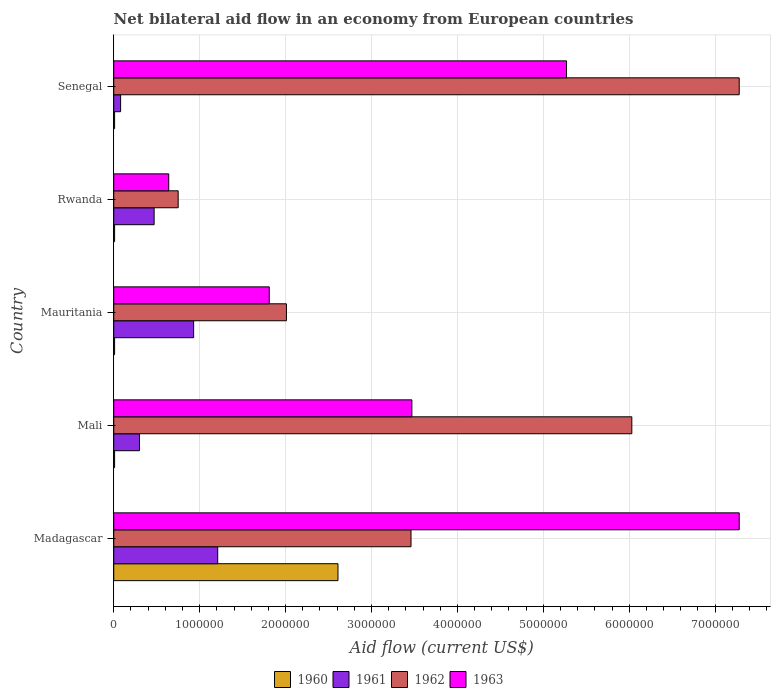How many groups of bars are there?
Your response must be concise. 5. How many bars are there on the 4th tick from the bottom?
Ensure brevity in your answer.  4. What is the label of the 1st group of bars from the top?
Provide a short and direct response. Senegal. What is the net bilateral aid flow in 1961 in Mauritania?
Your answer should be very brief. 9.30e+05. Across all countries, what is the maximum net bilateral aid flow in 1962?
Provide a succinct answer. 7.28e+06. Across all countries, what is the minimum net bilateral aid flow in 1963?
Your answer should be very brief. 6.40e+05. In which country was the net bilateral aid flow in 1961 maximum?
Your answer should be compact. Madagascar. In which country was the net bilateral aid flow in 1961 minimum?
Provide a succinct answer. Senegal. What is the total net bilateral aid flow in 1961 in the graph?
Your response must be concise. 2.99e+06. What is the difference between the net bilateral aid flow in 1962 in Mali and that in Senegal?
Your answer should be compact. -1.25e+06. What is the average net bilateral aid flow in 1961 per country?
Give a very brief answer. 5.98e+05. What is the difference between the net bilateral aid flow in 1962 and net bilateral aid flow in 1963 in Senegal?
Your answer should be very brief. 2.01e+06. What is the ratio of the net bilateral aid flow in 1963 in Mali to that in Senegal?
Your response must be concise. 0.66. Is the net bilateral aid flow in 1960 in Mauritania less than that in Rwanda?
Ensure brevity in your answer.  No. Is the difference between the net bilateral aid flow in 1962 in Mauritania and Senegal greater than the difference between the net bilateral aid flow in 1963 in Mauritania and Senegal?
Your answer should be very brief. No. What is the difference between the highest and the second highest net bilateral aid flow in 1961?
Offer a terse response. 2.80e+05. What is the difference between the highest and the lowest net bilateral aid flow in 1961?
Make the answer very short. 1.13e+06. In how many countries, is the net bilateral aid flow in 1962 greater than the average net bilateral aid flow in 1962 taken over all countries?
Offer a terse response. 2. Is the sum of the net bilateral aid flow in 1962 in Madagascar and Mali greater than the maximum net bilateral aid flow in 1960 across all countries?
Provide a short and direct response. Yes. What does the 1st bar from the top in Rwanda represents?
Offer a terse response. 1963. What does the 3rd bar from the bottom in Senegal represents?
Provide a succinct answer. 1962. Is it the case that in every country, the sum of the net bilateral aid flow in 1960 and net bilateral aid flow in 1962 is greater than the net bilateral aid flow in 1961?
Give a very brief answer. Yes. How many bars are there?
Your answer should be compact. 20. Are all the bars in the graph horizontal?
Offer a very short reply. Yes. Are the values on the major ticks of X-axis written in scientific E-notation?
Your answer should be compact. No. Does the graph contain grids?
Offer a terse response. Yes. Where does the legend appear in the graph?
Give a very brief answer. Bottom center. How many legend labels are there?
Offer a terse response. 4. How are the legend labels stacked?
Your answer should be compact. Horizontal. What is the title of the graph?
Give a very brief answer. Net bilateral aid flow in an economy from European countries. What is the label or title of the X-axis?
Your response must be concise. Aid flow (current US$). What is the label or title of the Y-axis?
Your answer should be compact. Country. What is the Aid flow (current US$) of 1960 in Madagascar?
Keep it short and to the point. 2.61e+06. What is the Aid flow (current US$) in 1961 in Madagascar?
Your response must be concise. 1.21e+06. What is the Aid flow (current US$) in 1962 in Madagascar?
Ensure brevity in your answer.  3.46e+06. What is the Aid flow (current US$) of 1963 in Madagascar?
Offer a very short reply. 7.28e+06. What is the Aid flow (current US$) of 1960 in Mali?
Provide a short and direct response. 10000. What is the Aid flow (current US$) of 1962 in Mali?
Offer a terse response. 6.03e+06. What is the Aid flow (current US$) in 1963 in Mali?
Your answer should be very brief. 3.47e+06. What is the Aid flow (current US$) in 1960 in Mauritania?
Offer a very short reply. 10000. What is the Aid flow (current US$) in 1961 in Mauritania?
Your response must be concise. 9.30e+05. What is the Aid flow (current US$) of 1962 in Mauritania?
Offer a very short reply. 2.01e+06. What is the Aid flow (current US$) of 1963 in Mauritania?
Provide a succinct answer. 1.81e+06. What is the Aid flow (current US$) in 1962 in Rwanda?
Provide a short and direct response. 7.50e+05. What is the Aid flow (current US$) in 1963 in Rwanda?
Your response must be concise. 6.40e+05. What is the Aid flow (current US$) in 1960 in Senegal?
Ensure brevity in your answer.  10000. What is the Aid flow (current US$) of 1961 in Senegal?
Make the answer very short. 8.00e+04. What is the Aid flow (current US$) in 1962 in Senegal?
Offer a very short reply. 7.28e+06. What is the Aid flow (current US$) of 1963 in Senegal?
Provide a succinct answer. 5.27e+06. Across all countries, what is the maximum Aid flow (current US$) of 1960?
Your answer should be compact. 2.61e+06. Across all countries, what is the maximum Aid flow (current US$) in 1961?
Provide a short and direct response. 1.21e+06. Across all countries, what is the maximum Aid flow (current US$) of 1962?
Provide a succinct answer. 7.28e+06. Across all countries, what is the maximum Aid flow (current US$) in 1963?
Your answer should be compact. 7.28e+06. Across all countries, what is the minimum Aid flow (current US$) of 1962?
Keep it short and to the point. 7.50e+05. Across all countries, what is the minimum Aid flow (current US$) in 1963?
Keep it short and to the point. 6.40e+05. What is the total Aid flow (current US$) in 1960 in the graph?
Give a very brief answer. 2.65e+06. What is the total Aid flow (current US$) of 1961 in the graph?
Keep it short and to the point. 2.99e+06. What is the total Aid flow (current US$) of 1962 in the graph?
Make the answer very short. 1.95e+07. What is the total Aid flow (current US$) in 1963 in the graph?
Your answer should be very brief. 1.85e+07. What is the difference between the Aid flow (current US$) in 1960 in Madagascar and that in Mali?
Your response must be concise. 2.60e+06. What is the difference between the Aid flow (current US$) in 1961 in Madagascar and that in Mali?
Provide a succinct answer. 9.10e+05. What is the difference between the Aid flow (current US$) in 1962 in Madagascar and that in Mali?
Your response must be concise. -2.57e+06. What is the difference between the Aid flow (current US$) of 1963 in Madagascar and that in Mali?
Your response must be concise. 3.81e+06. What is the difference between the Aid flow (current US$) in 1960 in Madagascar and that in Mauritania?
Provide a short and direct response. 2.60e+06. What is the difference between the Aid flow (current US$) in 1961 in Madagascar and that in Mauritania?
Your answer should be compact. 2.80e+05. What is the difference between the Aid flow (current US$) of 1962 in Madagascar and that in Mauritania?
Ensure brevity in your answer.  1.45e+06. What is the difference between the Aid flow (current US$) in 1963 in Madagascar and that in Mauritania?
Your response must be concise. 5.47e+06. What is the difference between the Aid flow (current US$) in 1960 in Madagascar and that in Rwanda?
Ensure brevity in your answer.  2.60e+06. What is the difference between the Aid flow (current US$) of 1961 in Madagascar and that in Rwanda?
Offer a very short reply. 7.40e+05. What is the difference between the Aid flow (current US$) in 1962 in Madagascar and that in Rwanda?
Your answer should be compact. 2.71e+06. What is the difference between the Aid flow (current US$) of 1963 in Madagascar and that in Rwanda?
Your answer should be very brief. 6.64e+06. What is the difference between the Aid flow (current US$) of 1960 in Madagascar and that in Senegal?
Your answer should be very brief. 2.60e+06. What is the difference between the Aid flow (current US$) in 1961 in Madagascar and that in Senegal?
Your answer should be compact. 1.13e+06. What is the difference between the Aid flow (current US$) of 1962 in Madagascar and that in Senegal?
Offer a terse response. -3.82e+06. What is the difference between the Aid flow (current US$) of 1963 in Madagascar and that in Senegal?
Make the answer very short. 2.01e+06. What is the difference between the Aid flow (current US$) of 1960 in Mali and that in Mauritania?
Your answer should be compact. 0. What is the difference between the Aid flow (current US$) of 1961 in Mali and that in Mauritania?
Provide a short and direct response. -6.30e+05. What is the difference between the Aid flow (current US$) of 1962 in Mali and that in Mauritania?
Your answer should be compact. 4.02e+06. What is the difference between the Aid flow (current US$) of 1963 in Mali and that in Mauritania?
Your answer should be compact. 1.66e+06. What is the difference between the Aid flow (current US$) of 1960 in Mali and that in Rwanda?
Keep it short and to the point. 0. What is the difference between the Aid flow (current US$) of 1961 in Mali and that in Rwanda?
Offer a terse response. -1.70e+05. What is the difference between the Aid flow (current US$) in 1962 in Mali and that in Rwanda?
Offer a very short reply. 5.28e+06. What is the difference between the Aid flow (current US$) of 1963 in Mali and that in Rwanda?
Your response must be concise. 2.83e+06. What is the difference between the Aid flow (current US$) in 1960 in Mali and that in Senegal?
Give a very brief answer. 0. What is the difference between the Aid flow (current US$) of 1961 in Mali and that in Senegal?
Ensure brevity in your answer.  2.20e+05. What is the difference between the Aid flow (current US$) of 1962 in Mali and that in Senegal?
Provide a succinct answer. -1.25e+06. What is the difference between the Aid flow (current US$) of 1963 in Mali and that in Senegal?
Your answer should be compact. -1.80e+06. What is the difference between the Aid flow (current US$) in 1961 in Mauritania and that in Rwanda?
Your answer should be compact. 4.60e+05. What is the difference between the Aid flow (current US$) of 1962 in Mauritania and that in Rwanda?
Ensure brevity in your answer.  1.26e+06. What is the difference between the Aid flow (current US$) in 1963 in Mauritania and that in Rwanda?
Offer a very short reply. 1.17e+06. What is the difference between the Aid flow (current US$) of 1960 in Mauritania and that in Senegal?
Keep it short and to the point. 0. What is the difference between the Aid flow (current US$) in 1961 in Mauritania and that in Senegal?
Provide a short and direct response. 8.50e+05. What is the difference between the Aid flow (current US$) in 1962 in Mauritania and that in Senegal?
Make the answer very short. -5.27e+06. What is the difference between the Aid flow (current US$) of 1963 in Mauritania and that in Senegal?
Make the answer very short. -3.46e+06. What is the difference between the Aid flow (current US$) of 1962 in Rwanda and that in Senegal?
Keep it short and to the point. -6.53e+06. What is the difference between the Aid flow (current US$) in 1963 in Rwanda and that in Senegal?
Ensure brevity in your answer.  -4.63e+06. What is the difference between the Aid flow (current US$) in 1960 in Madagascar and the Aid flow (current US$) in 1961 in Mali?
Provide a succinct answer. 2.31e+06. What is the difference between the Aid flow (current US$) in 1960 in Madagascar and the Aid flow (current US$) in 1962 in Mali?
Keep it short and to the point. -3.42e+06. What is the difference between the Aid flow (current US$) in 1960 in Madagascar and the Aid flow (current US$) in 1963 in Mali?
Offer a very short reply. -8.60e+05. What is the difference between the Aid flow (current US$) of 1961 in Madagascar and the Aid flow (current US$) of 1962 in Mali?
Provide a succinct answer. -4.82e+06. What is the difference between the Aid flow (current US$) of 1961 in Madagascar and the Aid flow (current US$) of 1963 in Mali?
Offer a very short reply. -2.26e+06. What is the difference between the Aid flow (current US$) in 1960 in Madagascar and the Aid flow (current US$) in 1961 in Mauritania?
Your answer should be compact. 1.68e+06. What is the difference between the Aid flow (current US$) of 1960 in Madagascar and the Aid flow (current US$) of 1963 in Mauritania?
Your answer should be very brief. 8.00e+05. What is the difference between the Aid flow (current US$) in 1961 in Madagascar and the Aid flow (current US$) in 1962 in Mauritania?
Provide a short and direct response. -8.00e+05. What is the difference between the Aid flow (current US$) of 1961 in Madagascar and the Aid flow (current US$) of 1963 in Mauritania?
Give a very brief answer. -6.00e+05. What is the difference between the Aid flow (current US$) in 1962 in Madagascar and the Aid flow (current US$) in 1963 in Mauritania?
Your answer should be very brief. 1.65e+06. What is the difference between the Aid flow (current US$) in 1960 in Madagascar and the Aid flow (current US$) in 1961 in Rwanda?
Your response must be concise. 2.14e+06. What is the difference between the Aid flow (current US$) in 1960 in Madagascar and the Aid flow (current US$) in 1962 in Rwanda?
Your answer should be very brief. 1.86e+06. What is the difference between the Aid flow (current US$) in 1960 in Madagascar and the Aid flow (current US$) in 1963 in Rwanda?
Your answer should be very brief. 1.97e+06. What is the difference between the Aid flow (current US$) in 1961 in Madagascar and the Aid flow (current US$) in 1962 in Rwanda?
Your answer should be very brief. 4.60e+05. What is the difference between the Aid flow (current US$) of 1961 in Madagascar and the Aid flow (current US$) of 1963 in Rwanda?
Your response must be concise. 5.70e+05. What is the difference between the Aid flow (current US$) in 1962 in Madagascar and the Aid flow (current US$) in 1963 in Rwanda?
Give a very brief answer. 2.82e+06. What is the difference between the Aid flow (current US$) in 1960 in Madagascar and the Aid flow (current US$) in 1961 in Senegal?
Offer a very short reply. 2.53e+06. What is the difference between the Aid flow (current US$) of 1960 in Madagascar and the Aid flow (current US$) of 1962 in Senegal?
Provide a succinct answer. -4.67e+06. What is the difference between the Aid flow (current US$) in 1960 in Madagascar and the Aid flow (current US$) in 1963 in Senegal?
Offer a very short reply. -2.66e+06. What is the difference between the Aid flow (current US$) in 1961 in Madagascar and the Aid flow (current US$) in 1962 in Senegal?
Your answer should be very brief. -6.07e+06. What is the difference between the Aid flow (current US$) of 1961 in Madagascar and the Aid flow (current US$) of 1963 in Senegal?
Your response must be concise. -4.06e+06. What is the difference between the Aid flow (current US$) in 1962 in Madagascar and the Aid flow (current US$) in 1963 in Senegal?
Your answer should be very brief. -1.81e+06. What is the difference between the Aid flow (current US$) in 1960 in Mali and the Aid flow (current US$) in 1961 in Mauritania?
Give a very brief answer. -9.20e+05. What is the difference between the Aid flow (current US$) of 1960 in Mali and the Aid flow (current US$) of 1963 in Mauritania?
Your answer should be compact. -1.80e+06. What is the difference between the Aid flow (current US$) in 1961 in Mali and the Aid flow (current US$) in 1962 in Mauritania?
Your answer should be compact. -1.71e+06. What is the difference between the Aid flow (current US$) of 1961 in Mali and the Aid flow (current US$) of 1963 in Mauritania?
Your answer should be compact. -1.51e+06. What is the difference between the Aid flow (current US$) in 1962 in Mali and the Aid flow (current US$) in 1963 in Mauritania?
Provide a short and direct response. 4.22e+06. What is the difference between the Aid flow (current US$) in 1960 in Mali and the Aid flow (current US$) in 1961 in Rwanda?
Give a very brief answer. -4.60e+05. What is the difference between the Aid flow (current US$) of 1960 in Mali and the Aid flow (current US$) of 1962 in Rwanda?
Your response must be concise. -7.40e+05. What is the difference between the Aid flow (current US$) in 1960 in Mali and the Aid flow (current US$) in 1963 in Rwanda?
Your answer should be compact. -6.30e+05. What is the difference between the Aid flow (current US$) of 1961 in Mali and the Aid flow (current US$) of 1962 in Rwanda?
Offer a terse response. -4.50e+05. What is the difference between the Aid flow (current US$) in 1962 in Mali and the Aid flow (current US$) in 1963 in Rwanda?
Provide a succinct answer. 5.39e+06. What is the difference between the Aid flow (current US$) of 1960 in Mali and the Aid flow (current US$) of 1962 in Senegal?
Ensure brevity in your answer.  -7.27e+06. What is the difference between the Aid flow (current US$) in 1960 in Mali and the Aid flow (current US$) in 1963 in Senegal?
Provide a succinct answer. -5.26e+06. What is the difference between the Aid flow (current US$) in 1961 in Mali and the Aid flow (current US$) in 1962 in Senegal?
Your response must be concise. -6.98e+06. What is the difference between the Aid flow (current US$) in 1961 in Mali and the Aid flow (current US$) in 1963 in Senegal?
Offer a terse response. -4.97e+06. What is the difference between the Aid flow (current US$) in 1962 in Mali and the Aid flow (current US$) in 1963 in Senegal?
Offer a very short reply. 7.60e+05. What is the difference between the Aid flow (current US$) in 1960 in Mauritania and the Aid flow (current US$) in 1961 in Rwanda?
Offer a terse response. -4.60e+05. What is the difference between the Aid flow (current US$) of 1960 in Mauritania and the Aid flow (current US$) of 1962 in Rwanda?
Offer a very short reply. -7.40e+05. What is the difference between the Aid flow (current US$) in 1960 in Mauritania and the Aid flow (current US$) in 1963 in Rwanda?
Provide a short and direct response. -6.30e+05. What is the difference between the Aid flow (current US$) in 1961 in Mauritania and the Aid flow (current US$) in 1962 in Rwanda?
Keep it short and to the point. 1.80e+05. What is the difference between the Aid flow (current US$) in 1961 in Mauritania and the Aid flow (current US$) in 1963 in Rwanda?
Your response must be concise. 2.90e+05. What is the difference between the Aid flow (current US$) of 1962 in Mauritania and the Aid flow (current US$) of 1963 in Rwanda?
Keep it short and to the point. 1.37e+06. What is the difference between the Aid flow (current US$) of 1960 in Mauritania and the Aid flow (current US$) of 1962 in Senegal?
Your response must be concise. -7.27e+06. What is the difference between the Aid flow (current US$) in 1960 in Mauritania and the Aid flow (current US$) in 1963 in Senegal?
Make the answer very short. -5.26e+06. What is the difference between the Aid flow (current US$) in 1961 in Mauritania and the Aid flow (current US$) in 1962 in Senegal?
Offer a terse response. -6.35e+06. What is the difference between the Aid flow (current US$) in 1961 in Mauritania and the Aid flow (current US$) in 1963 in Senegal?
Your answer should be compact. -4.34e+06. What is the difference between the Aid flow (current US$) of 1962 in Mauritania and the Aid flow (current US$) of 1963 in Senegal?
Your response must be concise. -3.26e+06. What is the difference between the Aid flow (current US$) in 1960 in Rwanda and the Aid flow (current US$) in 1962 in Senegal?
Your answer should be very brief. -7.27e+06. What is the difference between the Aid flow (current US$) of 1960 in Rwanda and the Aid flow (current US$) of 1963 in Senegal?
Your response must be concise. -5.26e+06. What is the difference between the Aid flow (current US$) in 1961 in Rwanda and the Aid flow (current US$) in 1962 in Senegal?
Provide a short and direct response. -6.81e+06. What is the difference between the Aid flow (current US$) of 1961 in Rwanda and the Aid flow (current US$) of 1963 in Senegal?
Your response must be concise. -4.80e+06. What is the difference between the Aid flow (current US$) in 1962 in Rwanda and the Aid flow (current US$) in 1963 in Senegal?
Provide a succinct answer. -4.52e+06. What is the average Aid flow (current US$) of 1960 per country?
Provide a short and direct response. 5.30e+05. What is the average Aid flow (current US$) of 1961 per country?
Your answer should be very brief. 5.98e+05. What is the average Aid flow (current US$) in 1962 per country?
Your answer should be very brief. 3.91e+06. What is the average Aid flow (current US$) of 1963 per country?
Keep it short and to the point. 3.69e+06. What is the difference between the Aid flow (current US$) in 1960 and Aid flow (current US$) in 1961 in Madagascar?
Your answer should be compact. 1.40e+06. What is the difference between the Aid flow (current US$) of 1960 and Aid flow (current US$) of 1962 in Madagascar?
Provide a short and direct response. -8.50e+05. What is the difference between the Aid flow (current US$) of 1960 and Aid flow (current US$) of 1963 in Madagascar?
Your answer should be compact. -4.67e+06. What is the difference between the Aid flow (current US$) in 1961 and Aid flow (current US$) in 1962 in Madagascar?
Give a very brief answer. -2.25e+06. What is the difference between the Aid flow (current US$) in 1961 and Aid flow (current US$) in 1963 in Madagascar?
Give a very brief answer. -6.07e+06. What is the difference between the Aid flow (current US$) of 1962 and Aid flow (current US$) of 1963 in Madagascar?
Your response must be concise. -3.82e+06. What is the difference between the Aid flow (current US$) of 1960 and Aid flow (current US$) of 1962 in Mali?
Provide a short and direct response. -6.02e+06. What is the difference between the Aid flow (current US$) in 1960 and Aid flow (current US$) in 1963 in Mali?
Give a very brief answer. -3.46e+06. What is the difference between the Aid flow (current US$) in 1961 and Aid flow (current US$) in 1962 in Mali?
Provide a succinct answer. -5.73e+06. What is the difference between the Aid flow (current US$) of 1961 and Aid flow (current US$) of 1963 in Mali?
Ensure brevity in your answer.  -3.17e+06. What is the difference between the Aid flow (current US$) of 1962 and Aid flow (current US$) of 1963 in Mali?
Offer a terse response. 2.56e+06. What is the difference between the Aid flow (current US$) of 1960 and Aid flow (current US$) of 1961 in Mauritania?
Your response must be concise. -9.20e+05. What is the difference between the Aid flow (current US$) of 1960 and Aid flow (current US$) of 1962 in Mauritania?
Give a very brief answer. -2.00e+06. What is the difference between the Aid flow (current US$) in 1960 and Aid flow (current US$) in 1963 in Mauritania?
Ensure brevity in your answer.  -1.80e+06. What is the difference between the Aid flow (current US$) of 1961 and Aid flow (current US$) of 1962 in Mauritania?
Provide a succinct answer. -1.08e+06. What is the difference between the Aid flow (current US$) in 1961 and Aid flow (current US$) in 1963 in Mauritania?
Provide a short and direct response. -8.80e+05. What is the difference between the Aid flow (current US$) in 1962 and Aid flow (current US$) in 1963 in Mauritania?
Make the answer very short. 2.00e+05. What is the difference between the Aid flow (current US$) of 1960 and Aid flow (current US$) of 1961 in Rwanda?
Provide a succinct answer. -4.60e+05. What is the difference between the Aid flow (current US$) in 1960 and Aid flow (current US$) in 1962 in Rwanda?
Offer a very short reply. -7.40e+05. What is the difference between the Aid flow (current US$) of 1960 and Aid flow (current US$) of 1963 in Rwanda?
Your answer should be compact. -6.30e+05. What is the difference between the Aid flow (current US$) in 1961 and Aid flow (current US$) in 1962 in Rwanda?
Your answer should be very brief. -2.80e+05. What is the difference between the Aid flow (current US$) in 1961 and Aid flow (current US$) in 1963 in Rwanda?
Offer a terse response. -1.70e+05. What is the difference between the Aid flow (current US$) in 1960 and Aid flow (current US$) in 1962 in Senegal?
Offer a terse response. -7.27e+06. What is the difference between the Aid flow (current US$) of 1960 and Aid flow (current US$) of 1963 in Senegal?
Offer a terse response. -5.26e+06. What is the difference between the Aid flow (current US$) in 1961 and Aid flow (current US$) in 1962 in Senegal?
Offer a very short reply. -7.20e+06. What is the difference between the Aid flow (current US$) of 1961 and Aid flow (current US$) of 1963 in Senegal?
Your answer should be compact. -5.19e+06. What is the difference between the Aid flow (current US$) in 1962 and Aid flow (current US$) in 1963 in Senegal?
Provide a succinct answer. 2.01e+06. What is the ratio of the Aid flow (current US$) of 1960 in Madagascar to that in Mali?
Keep it short and to the point. 261. What is the ratio of the Aid flow (current US$) in 1961 in Madagascar to that in Mali?
Your answer should be compact. 4.03. What is the ratio of the Aid flow (current US$) in 1962 in Madagascar to that in Mali?
Your response must be concise. 0.57. What is the ratio of the Aid flow (current US$) in 1963 in Madagascar to that in Mali?
Keep it short and to the point. 2.1. What is the ratio of the Aid flow (current US$) in 1960 in Madagascar to that in Mauritania?
Ensure brevity in your answer.  261. What is the ratio of the Aid flow (current US$) in 1961 in Madagascar to that in Mauritania?
Ensure brevity in your answer.  1.3. What is the ratio of the Aid flow (current US$) of 1962 in Madagascar to that in Mauritania?
Provide a short and direct response. 1.72. What is the ratio of the Aid flow (current US$) of 1963 in Madagascar to that in Mauritania?
Offer a terse response. 4.02. What is the ratio of the Aid flow (current US$) of 1960 in Madagascar to that in Rwanda?
Offer a terse response. 261. What is the ratio of the Aid flow (current US$) in 1961 in Madagascar to that in Rwanda?
Your response must be concise. 2.57. What is the ratio of the Aid flow (current US$) of 1962 in Madagascar to that in Rwanda?
Provide a short and direct response. 4.61. What is the ratio of the Aid flow (current US$) of 1963 in Madagascar to that in Rwanda?
Keep it short and to the point. 11.38. What is the ratio of the Aid flow (current US$) of 1960 in Madagascar to that in Senegal?
Offer a very short reply. 261. What is the ratio of the Aid flow (current US$) of 1961 in Madagascar to that in Senegal?
Your answer should be compact. 15.12. What is the ratio of the Aid flow (current US$) of 1962 in Madagascar to that in Senegal?
Give a very brief answer. 0.48. What is the ratio of the Aid flow (current US$) of 1963 in Madagascar to that in Senegal?
Provide a succinct answer. 1.38. What is the ratio of the Aid flow (current US$) in 1961 in Mali to that in Mauritania?
Provide a short and direct response. 0.32. What is the ratio of the Aid flow (current US$) of 1963 in Mali to that in Mauritania?
Keep it short and to the point. 1.92. What is the ratio of the Aid flow (current US$) of 1960 in Mali to that in Rwanda?
Your answer should be very brief. 1. What is the ratio of the Aid flow (current US$) in 1961 in Mali to that in Rwanda?
Keep it short and to the point. 0.64. What is the ratio of the Aid flow (current US$) in 1962 in Mali to that in Rwanda?
Ensure brevity in your answer.  8.04. What is the ratio of the Aid flow (current US$) in 1963 in Mali to that in Rwanda?
Make the answer very short. 5.42. What is the ratio of the Aid flow (current US$) in 1961 in Mali to that in Senegal?
Ensure brevity in your answer.  3.75. What is the ratio of the Aid flow (current US$) in 1962 in Mali to that in Senegal?
Keep it short and to the point. 0.83. What is the ratio of the Aid flow (current US$) of 1963 in Mali to that in Senegal?
Offer a terse response. 0.66. What is the ratio of the Aid flow (current US$) in 1960 in Mauritania to that in Rwanda?
Offer a terse response. 1. What is the ratio of the Aid flow (current US$) of 1961 in Mauritania to that in Rwanda?
Keep it short and to the point. 1.98. What is the ratio of the Aid flow (current US$) of 1962 in Mauritania to that in Rwanda?
Provide a short and direct response. 2.68. What is the ratio of the Aid flow (current US$) in 1963 in Mauritania to that in Rwanda?
Keep it short and to the point. 2.83. What is the ratio of the Aid flow (current US$) of 1961 in Mauritania to that in Senegal?
Keep it short and to the point. 11.62. What is the ratio of the Aid flow (current US$) in 1962 in Mauritania to that in Senegal?
Offer a very short reply. 0.28. What is the ratio of the Aid flow (current US$) of 1963 in Mauritania to that in Senegal?
Your answer should be very brief. 0.34. What is the ratio of the Aid flow (current US$) of 1961 in Rwanda to that in Senegal?
Provide a short and direct response. 5.88. What is the ratio of the Aid flow (current US$) of 1962 in Rwanda to that in Senegal?
Offer a terse response. 0.1. What is the ratio of the Aid flow (current US$) in 1963 in Rwanda to that in Senegal?
Ensure brevity in your answer.  0.12. What is the difference between the highest and the second highest Aid flow (current US$) in 1960?
Your answer should be very brief. 2.60e+06. What is the difference between the highest and the second highest Aid flow (current US$) in 1962?
Your answer should be very brief. 1.25e+06. What is the difference between the highest and the second highest Aid flow (current US$) in 1963?
Keep it short and to the point. 2.01e+06. What is the difference between the highest and the lowest Aid flow (current US$) of 1960?
Make the answer very short. 2.60e+06. What is the difference between the highest and the lowest Aid flow (current US$) in 1961?
Offer a very short reply. 1.13e+06. What is the difference between the highest and the lowest Aid flow (current US$) of 1962?
Offer a terse response. 6.53e+06. What is the difference between the highest and the lowest Aid flow (current US$) of 1963?
Keep it short and to the point. 6.64e+06. 